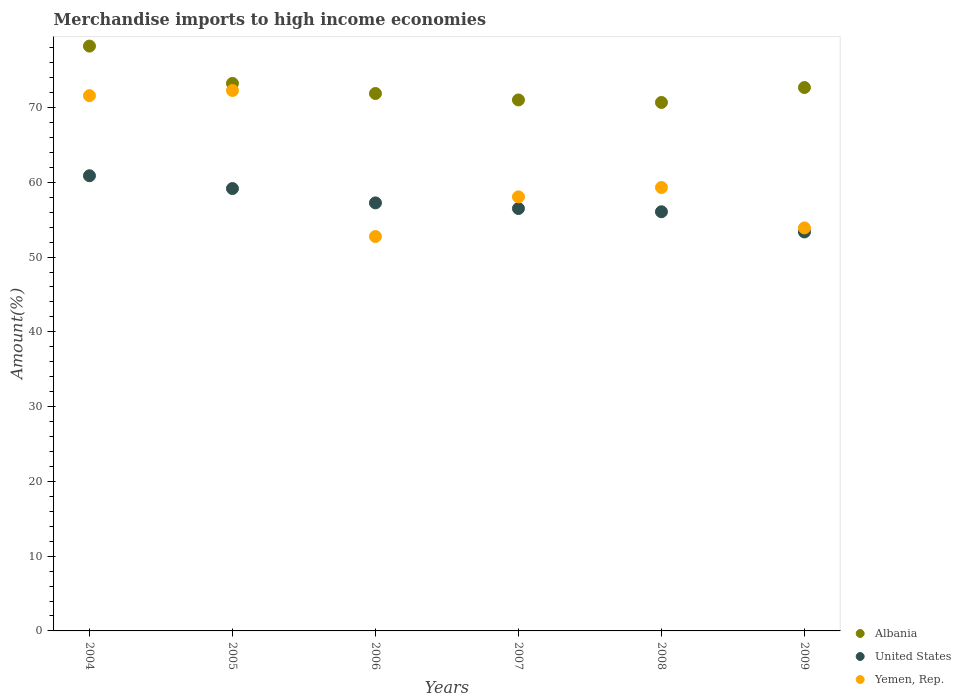How many different coloured dotlines are there?
Provide a succinct answer. 3. What is the percentage of amount earned from merchandise imports in Yemen, Rep. in 2004?
Offer a terse response. 71.59. Across all years, what is the maximum percentage of amount earned from merchandise imports in United States?
Your answer should be very brief. 60.88. Across all years, what is the minimum percentage of amount earned from merchandise imports in United States?
Ensure brevity in your answer.  53.36. In which year was the percentage of amount earned from merchandise imports in Albania maximum?
Offer a terse response. 2004. In which year was the percentage of amount earned from merchandise imports in Albania minimum?
Your answer should be very brief. 2008. What is the total percentage of amount earned from merchandise imports in Yemen, Rep. in the graph?
Give a very brief answer. 367.88. What is the difference between the percentage of amount earned from merchandise imports in United States in 2007 and that in 2008?
Offer a terse response. 0.43. What is the difference between the percentage of amount earned from merchandise imports in Albania in 2008 and the percentage of amount earned from merchandise imports in United States in 2007?
Keep it short and to the point. 14.19. What is the average percentage of amount earned from merchandise imports in Yemen, Rep. per year?
Provide a short and direct response. 61.31. In the year 2008, what is the difference between the percentage of amount earned from merchandise imports in Albania and percentage of amount earned from merchandise imports in United States?
Make the answer very short. 14.62. What is the ratio of the percentage of amount earned from merchandise imports in United States in 2004 to that in 2006?
Make the answer very short. 1.06. Is the percentage of amount earned from merchandise imports in Yemen, Rep. in 2006 less than that in 2007?
Provide a succinct answer. Yes. Is the difference between the percentage of amount earned from merchandise imports in Albania in 2006 and 2009 greater than the difference between the percentage of amount earned from merchandise imports in United States in 2006 and 2009?
Make the answer very short. No. What is the difference between the highest and the second highest percentage of amount earned from merchandise imports in Yemen, Rep.?
Your answer should be very brief. 0.69. What is the difference between the highest and the lowest percentage of amount earned from merchandise imports in Yemen, Rep.?
Offer a very short reply. 19.53. In how many years, is the percentage of amount earned from merchandise imports in Yemen, Rep. greater than the average percentage of amount earned from merchandise imports in Yemen, Rep. taken over all years?
Your answer should be very brief. 2. Is the sum of the percentage of amount earned from merchandise imports in Albania in 2006 and 2009 greater than the maximum percentage of amount earned from merchandise imports in Yemen, Rep. across all years?
Your answer should be very brief. Yes. Does the percentage of amount earned from merchandise imports in United States monotonically increase over the years?
Your answer should be very brief. No. How many dotlines are there?
Make the answer very short. 3. How many years are there in the graph?
Offer a terse response. 6. What is the difference between two consecutive major ticks on the Y-axis?
Provide a short and direct response. 10. Are the values on the major ticks of Y-axis written in scientific E-notation?
Make the answer very short. No. Does the graph contain any zero values?
Your answer should be very brief. No. What is the title of the graph?
Your answer should be very brief. Merchandise imports to high income economies. Does "Cote d'Ivoire" appear as one of the legend labels in the graph?
Give a very brief answer. No. What is the label or title of the Y-axis?
Ensure brevity in your answer.  Amount(%). What is the Amount(%) in Albania in 2004?
Your response must be concise. 78.22. What is the Amount(%) in United States in 2004?
Provide a succinct answer. 60.88. What is the Amount(%) in Yemen, Rep. in 2004?
Your answer should be compact. 71.59. What is the Amount(%) of Albania in 2005?
Provide a succinct answer. 73.23. What is the Amount(%) in United States in 2005?
Provide a succinct answer. 59.17. What is the Amount(%) in Yemen, Rep. in 2005?
Provide a succinct answer. 72.28. What is the Amount(%) of Albania in 2006?
Your answer should be very brief. 71.88. What is the Amount(%) of United States in 2006?
Provide a short and direct response. 57.25. What is the Amount(%) in Yemen, Rep. in 2006?
Provide a short and direct response. 52.75. What is the Amount(%) of Albania in 2007?
Keep it short and to the point. 71.02. What is the Amount(%) in United States in 2007?
Ensure brevity in your answer.  56.49. What is the Amount(%) in Yemen, Rep. in 2007?
Your response must be concise. 58.05. What is the Amount(%) of Albania in 2008?
Your response must be concise. 70.68. What is the Amount(%) of United States in 2008?
Your answer should be compact. 56.06. What is the Amount(%) in Yemen, Rep. in 2008?
Offer a terse response. 59.31. What is the Amount(%) of Albania in 2009?
Your answer should be compact. 72.68. What is the Amount(%) in United States in 2009?
Ensure brevity in your answer.  53.36. What is the Amount(%) in Yemen, Rep. in 2009?
Make the answer very short. 53.9. Across all years, what is the maximum Amount(%) of Albania?
Your response must be concise. 78.22. Across all years, what is the maximum Amount(%) of United States?
Your answer should be very brief. 60.88. Across all years, what is the maximum Amount(%) in Yemen, Rep.?
Give a very brief answer. 72.28. Across all years, what is the minimum Amount(%) in Albania?
Give a very brief answer. 70.68. Across all years, what is the minimum Amount(%) of United States?
Offer a very short reply. 53.36. Across all years, what is the minimum Amount(%) of Yemen, Rep.?
Offer a very short reply. 52.75. What is the total Amount(%) of Albania in the graph?
Offer a terse response. 437.71. What is the total Amount(%) in United States in the graph?
Provide a succinct answer. 343.21. What is the total Amount(%) in Yemen, Rep. in the graph?
Offer a very short reply. 367.88. What is the difference between the Amount(%) of Albania in 2004 and that in 2005?
Give a very brief answer. 4.99. What is the difference between the Amount(%) in United States in 2004 and that in 2005?
Offer a very short reply. 1.71. What is the difference between the Amount(%) in Yemen, Rep. in 2004 and that in 2005?
Give a very brief answer. -0.69. What is the difference between the Amount(%) of Albania in 2004 and that in 2006?
Provide a short and direct response. 6.34. What is the difference between the Amount(%) of United States in 2004 and that in 2006?
Give a very brief answer. 3.63. What is the difference between the Amount(%) of Yemen, Rep. in 2004 and that in 2006?
Offer a terse response. 18.84. What is the difference between the Amount(%) of Albania in 2004 and that in 2007?
Your response must be concise. 7.2. What is the difference between the Amount(%) in United States in 2004 and that in 2007?
Provide a short and direct response. 4.39. What is the difference between the Amount(%) of Yemen, Rep. in 2004 and that in 2007?
Provide a succinct answer. 13.54. What is the difference between the Amount(%) of Albania in 2004 and that in 2008?
Make the answer very short. 7.54. What is the difference between the Amount(%) of United States in 2004 and that in 2008?
Keep it short and to the point. 4.82. What is the difference between the Amount(%) of Yemen, Rep. in 2004 and that in 2008?
Offer a terse response. 12.28. What is the difference between the Amount(%) of Albania in 2004 and that in 2009?
Offer a terse response. 5.54. What is the difference between the Amount(%) in United States in 2004 and that in 2009?
Offer a very short reply. 7.52. What is the difference between the Amount(%) in Yemen, Rep. in 2004 and that in 2009?
Keep it short and to the point. 17.69. What is the difference between the Amount(%) of Albania in 2005 and that in 2006?
Your answer should be very brief. 1.35. What is the difference between the Amount(%) in United States in 2005 and that in 2006?
Make the answer very short. 1.92. What is the difference between the Amount(%) in Yemen, Rep. in 2005 and that in 2006?
Give a very brief answer. 19.53. What is the difference between the Amount(%) in Albania in 2005 and that in 2007?
Provide a short and direct response. 2.21. What is the difference between the Amount(%) of United States in 2005 and that in 2007?
Make the answer very short. 2.67. What is the difference between the Amount(%) in Yemen, Rep. in 2005 and that in 2007?
Provide a short and direct response. 14.23. What is the difference between the Amount(%) of Albania in 2005 and that in 2008?
Your answer should be very brief. 2.55. What is the difference between the Amount(%) of United States in 2005 and that in 2008?
Your answer should be very brief. 3.1. What is the difference between the Amount(%) in Yemen, Rep. in 2005 and that in 2008?
Ensure brevity in your answer.  12.98. What is the difference between the Amount(%) of Albania in 2005 and that in 2009?
Offer a terse response. 0.55. What is the difference between the Amount(%) in United States in 2005 and that in 2009?
Keep it short and to the point. 5.8. What is the difference between the Amount(%) in Yemen, Rep. in 2005 and that in 2009?
Provide a succinct answer. 18.38. What is the difference between the Amount(%) of Albania in 2006 and that in 2007?
Give a very brief answer. 0.86. What is the difference between the Amount(%) in United States in 2006 and that in 2007?
Give a very brief answer. 0.76. What is the difference between the Amount(%) of Yemen, Rep. in 2006 and that in 2007?
Give a very brief answer. -5.3. What is the difference between the Amount(%) in Albania in 2006 and that in 2008?
Give a very brief answer. 1.2. What is the difference between the Amount(%) in United States in 2006 and that in 2008?
Your answer should be very brief. 1.19. What is the difference between the Amount(%) of Yemen, Rep. in 2006 and that in 2008?
Give a very brief answer. -6.56. What is the difference between the Amount(%) in Albania in 2006 and that in 2009?
Give a very brief answer. -0.8. What is the difference between the Amount(%) in United States in 2006 and that in 2009?
Your response must be concise. 3.89. What is the difference between the Amount(%) in Yemen, Rep. in 2006 and that in 2009?
Your answer should be very brief. -1.15. What is the difference between the Amount(%) of Albania in 2007 and that in 2008?
Your response must be concise. 0.34. What is the difference between the Amount(%) in United States in 2007 and that in 2008?
Ensure brevity in your answer.  0.43. What is the difference between the Amount(%) of Yemen, Rep. in 2007 and that in 2008?
Give a very brief answer. -1.25. What is the difference between the Amount(%) in Albania in 2007 and that in 2009?
Provide a short and direct response. -1.66. What is the difference between the Amount(%) of United States in 2007 and that in 2009?
Offer a very short reply. 3.13. What is the difference between the Amount(%) in Yemen, Rep. in 2007 and that in 2009?
Give a very brief answer. 4.15. What is the difference between the Amount(%) of Albania in 2008 and that in 2009?
Offer a terse response. -2. What is the difference between the Amount(%) of United States in 2008 and that in 2009?
Your answer should be very brief. 2.7. What is the difference between the Amount(%) of Yemen, Rep. in 2008 and that in 2009?
Your answer should be very brief. 5.4. What is the difference between the Amount(%) in Albania in 2004 and the Amount(%) in United States in 2005?
Keep it short and to the point. 19.05. What is the difference between the Amount(%) of Albania in 2004 and the Amount(%) of Yemen, Rep. in 2005?
Offer a very short reply. 5.94. What is the difference between the Amount(%) of United States in 2004 and the Amount(%) of Yemen, Rep. in 2005?
Ensure brevity in your answer.  -11.4. What is the difference between the Amount(%) of Albania in 2004 and the Amount(%) of United States in 2006?
Your answer should be compact. 20.97. What is the difference between the Amount(%) in Albania in 2004 and the Amount(%) in Yemen, Rep. in 2006?
Provide a succinct answer. 25.47. What is the difference between the Amount(%) of United States in 2004 and the Amount(%) of Yemen, Rep. in 2006?
Provide a short and direct response. 8.13. What is the difference between the Amount(%) in Albania in 2004 and the Amount(%) in United States in 2007?
Your response must be concise. 21.73. What is the difference between the Amount(%) of Albania in 2004 and the Amount(%) of Yemen, Rep. in 2007?
Offer a very short reply. 20.17. What is the difference between the Amount(%) of United States in 2004 and the Amount(%) of Yemen, Rep. in 2007?
Provide a short and direct response. 2.83. What is the difference between the Amount(%) of Albania in 2004 and the Amount(%) of United States in 2008?
Provide a succinct answer. 22.16. What is the difference between the Amount(%) of Albania in 2004 and the Amount(%) of Yemen, Rep. in 2008?
Provide a short and direct response. 18.91. What is the difference between the Amount(%) of United States in 2004 and the Amount(%) of Yemen, Rep. in 2008?
Provide a succinct answer. 1.57. What is the difference between the Amount(%) in Albania in 2004 and the Amount(%) in United States in 2009?
Ensure brevity in your answer.  24.86. What is the difference between the Amount(%) of Albania in 2004 and the Amount(%) of Yemen, Rep. in 2009?
Ensure brevity in your answer.  24.32. What is the difference between the Amount(%) in United States in 2004 and the Amount(%) in Yemen, Rep. in 2009?
Make the answer very short. 6.98. What is the difference between the Amount(%) of Albania in 2005 and the Amount(%) of United States in 2006?
Your answer should be very brief. 15.98. What is the difference between the Amount(%) of Albania in 2005 and the Amount(%) of Yemen, Rep. in 2006?
Provide a succinct answer. 20.48. What is the difference between the Amount(%) of United States in 2005 and the Amount(%) of Yemen, Rep. in 2006?
Offer a very short reply. 6.42. What is the difference between the Amount(%) in Albania in 2005 and the Amount(%) in United States in 2007?
Provide a short and direct response. 16.74. What is the difference between the Amount(%) of Albania in 2005 and the Amount(%) of Yemen, Rep. in 2007?
Provide a succinct answer. 15.18. What is the difference between the Amount(%) in United States in 2005 and the Amount(%) in Yemen, Rep. in 2007?
Your response must be concise. 1.11. What is the difference between the Amount(%) of Albania in 2005 and the Amount(%) of United States in 2008?
Provide a short and direct response. 17.17. What is the difference between the Amount(%) of Albania in 2005 and the Amount(%) of Yemen, Rep. in 2008?
Provide a short and direct response. 13.92. What is the difference between the Amount(%) of United States in 2005 and the Amount(%) of Yemen, Rep. in 2008?
Ensure brevity in your answer.  -0.14. What is the difference between the Amount(%) of Albania in 2005 and the Amount(%) of United States in 2009?
Make the answer very short. 19.87. What is the difference between the Amount(%) of Albania in 2005 and the Amount(%) of Yemen, Rep. in 2009?
Make the answer very short. 19.33. What is the difference between the Amount(%) in United States in 2005 and the Amount(%) in Yemen, Rep. in 2009?
Keep it short and to the point. 5.26. What is the difference between the Amount(%) in Albania in 2006 and the Amount(%) in United States in 2007?
Offer a terse response. 15.39. What is the difference between the Amount(%) of Albania in 2006 and the Amount(%) of Yemen, Rep. in 2007?
Ensure brevity in your answer.  13.83. What is the difference between the Amount(%) of United States in 2006 and the Amount(%) of Yemen, Rep. in 2007?
Keep it short and to the point. -0.8. What is the difference between the Amount(%) of Albania in 2006 and the Amount(%) of United States in 2008?
Give a very brief answer. 15.82. What is the difference between the Amount(%) of Albania in 2006 and the Amount(%) of Yemen, Rep. in 2008?
Give a very brief answer. 12.57. What is the difference between the Amount(%) in United States in 2006 and the Amount(%) in Yemen, Rep. in 2008?
Provide a short and direct response. -2.06. What is the difference between the Amount(%) of Albania in 2006 and the Amount(%) of United States in 2009?
Keep it short and to the point. 18.52. What is the difference between the Amount(%) in Albania in 2006 and the Amount(%) in Yemen, Rep. in 2009?
Offer a terse response. 17.98. What is the difference between the Amount(%) of United States in 2006 and the Amount(%) of Yemen, Rep. in 2009?
Ensure brevity in your answer.  3.35. What is the difference between the Amount(%) in Albania in 2007 and the Amount(%) in United States in 2008?
Provide a short and direct response. 14.96. What is the difference between the Amount(%) in Albania in 2007 and the Amount(%) in Yemen, Rep. in 2008?
Give a very brief answer. 11.71. What is the difference between the Amount(%) of United States in 2007 and the Amount(%) of Yemen, Rep. in 2008?
Keep it short and to the point. -2.81. What is the difference between the Amount(%) in Albania in 2007 and the Amount(%) in United States in 2009?
Provide a succinct answer. 17.66. What is the difference between the Amount(%) in Albania in 2007 and the Amount(%) in Yemen, Rep. in 2009?
Give a very brief answer. 17.12. What is the difference between the Amount(%) in United States in 2007 and the Amount(%) in Yemen, Rep. in 2009?
Offer a very short reply. 2.59. What is the difference between the Amount(%) of Albania in 2008 and the Amount(%) of United States in 2009?
Ensure brevity in your answer.  17.32. What is the difference between the Amount(%) of Albania in 2008 and the Amount(%) of Yemen, Rep. in 2009?
Give a very brief answer. 16.78. What is the difference between the Amount(%) in United States in 2008 and the Amount(%) in Yemen, Rep. in 2009?
Your answer should be compact. 2.16. What is the average Amount(%) of Albania per year?
Keep it short and to the point. 72.95. What is the average Amount(%) of United States per year?
Your answer should be very brief. 57.2. What is the average Amount(%) of Yemen, Rep. per year?
Give a very brief answer. 61.31. In the year 2004, what is the difference between the Amount(%) in Albania and Amount(%) in United States?
Provide a succinct answer. 17.34. In the year 2004, what is the difference between the Amount(%) of Albania and Amount(%) of Yemen, Rep.?
Keep it short and to the point. 6.63. In the year 2004, what is the difference between the Amount(%) in United States and Amount(%) in Yemen, Rep.?
Ensure brevity in your answer.  -10.71. In the year 2005, what is the difference between the Amount(%) in Albania and Amount(%) in United States?
Provide a short and direct response. 14.06. In the year 2005, what is the difference between the Amount(%) of Albania and Amount(%) of Yemen, Rep.?
Provide a succinct answer. 0.95. In the year 2005, what is the difference between the Amount(%) of United States and Amount(%) of Yemen, Rep.?
Your response must be concise. -13.12. In the year 2006, what is the difference between the Amount(%) of Albania and Amount(%) of United States?
Your response must be concise. 14.63. In the year 2006, what is the difference between the Amount(%) in Albania and Amount(%) in Yemen, Rep.?
Your answer should be very brief. 19.13. In the year 2006, what is the difference between the Amount(%) of United States and Amount(%) of Yemen, Rep.?
Your response must be concise. 4.5. In the year 2007, what is the difference between the Amount(%) in Albania and Amount(%) in United States?
Offer a terse response. 14.53. In the year 2007, what is the difference between the Amount(%) of Albania and Amount(%) of Yemen, Rep.?
Keep it short and to the point. 12.97. In the year 2007, what is the difference between the Amount(%) of United States and Amount(%) of Yemen, Rep.?
Your response must be concise. -1.56. In the year 2008, what is the difference between the Amount(%) of Albania and Amount(%) of United States?
Provide a succinct answer. 14.62. In the year 2008, what is the difference between the Amount(%) in Albania and Amount(%) in Yemen, Rep.?
Make the answer very short. 11.37. In the year 2008, what is the difference between the Amount(%) of United States and Amount(%) of Yemen, Rep.?
Ensure brevity in your answer.  -3.24. In the year 2009, what is the difference between the Amount(%) of Albania and Amount(%) of United States?
Your response must be concise. 19.32. In the year 2009, what is the difference between the Amount(%) of Albania and Amount(%) of Yemen, Rep.?
Provide a succinct answer. 18.78. In the year 2009, what is the difference between the Amount(%) in United States and Amount(%) in Yemen, Rep.?
Give a very brief answer. -0.54. What is the ratio of the Amount(%) in Albania in 2004 to that in 2005?
Your answer should be compact. 1.07. What is the ratio of the Amount(%) of United States in 2004 to that in 2005?
Your answer should be very brief. 1.03. What is the ratio of the Amount(%) of Albania in 2004 to that in 2006?
Offer a terse response. 1.09. What is the ratio of the Amount(%) of United States in 2004 to that in 2006?
Your answer should be very brief. 1.06. What is the ratio of the Amount(%) of Yemen, Rep. in 2004 to that in 2006?
Ensure brevity in your answer.  1.36. What is the ratio of the Amount(%) in Albania in 2004 to that in 2007?
Provide a succinct answer. 1.1. What is the ratio of the Amount(%) of United States in 2004 to that in 2007?
Provide a short and direct response. 1.08. What is the ratio of the Amount(%) in Yemen, Rep. in 2004 to that in 2007?
Provide a succinct answer. 1.23. What is the ratio of the Amount(%) in Albania in 2004 to that in 2008?
Make the answer very short. 1.11. What is the ratio of the Amount(%) of United States in 2004 to that in 2008?
Your answer should be compact. 1.09. What is the ratio of the Amount(%) of Yemen, Rep. in 2004 to that in 2008?
Provide a succinct answer. 1.21. What is the ratio of the Amount(%) in Albania in 2004 to that in 2009?
Provide a succinct answer. 1.08. What is the ratio of the Amount(%) in United States in 2004 to that in 2009?
Your answer should be compact. 1.14. What is the ratio of the Amount(%) in Yemen, Rep. in 2004 to that in 2009?
Provide a succinct answer. 1.33. What is the ratio of the Amount(%) in Albania in 2005 to that in 2006?
Provide a succinct answer. 1.02. What is the ratio of the Amount(%) in United States in 2005 to that in 2006?
Your answer should be very brief. 1.03. What is the ratio of the Amount(%) in Yemen, Rep. in 2005 to that in 2006?
Offer a terse response. 1.37. What is the ratio of the Amount(%) of Albania in 2005 to that in 2007?
Offer a very short reply. 1.03. What is the ratio of the Amount(%) of United States in 2005 to that in 2007?
Provide a succinct answer. 1.05. What is the ratio of the Amount(%) in Yemen, Rep. in 2005 to that in 2007?
Give a very brief answer. 1.25. What is the ratio of the Amount(%) of Albania in 2005 to that in 2008?
Keep it short and to the point. 1.04. What is the ratio of the Amount(%) in United States in 2005 to that in 2008?
Offer a very short reply. 1.06. What is the ratio of the Amount(%) in Yemen, Rep. in 2005 to that in 2008?
Ensure brevity in your answer.  1.22. What is the ratio of the Amount(%) in Albania in 2005 to that in 2009?
Your answer should be very brief. 1.01. What is the ratio of the Amount(%) in United States in 2005 to that in 2009?
Offer a terse response. 1.11. What is the ratio of the Amount(%) in Yemen, Rep. in 2005 to that in 2009?
Offer a very short reply. 1.34. What is the ratio of the Amount(%) of Albania in 2006 to that in 2007?
Your response must be concise. 1.01. What is the ratio of the Amount(%) of United States in 2006 to that in 2007?
Provide a short and direct response. 1.01. What is the ratio of the Amount(%) of Yemen, Rep. in 2006 to that in 2007?
Offer a very short reply. 0.91. What is the ratio of the Amount(%) in Albania in 2006 to that in 2008?
Your response must be concise. 1.02. What is the ratio of the Amount(%) of United States in 2006 to that in 2008?
Provide a short and direct response. 1.02. What is the ratio of the Amount(%) of Yemen, Rep. in 2006 to that in 2008?
Keep it short and to the point. 0.89. What is the ratio of the Amount(%) in Albania in 2006 to that in 2009?
Your response must be concise. 0.99. What is the ratio of the Amount(%) in United States in 2006 to that in 2009?
Your answer should be compact. 1.07. What is the ratio of the Amount(%) of Yemen, Rep. in 2006 to that in 2009?
Make the answer very short. 0.98. What is the ratio of the Amount(%) in United States in 2007 to that in 2008?
Ensure brevity in your answer.  1.01. What is the ratio of the Amount(%) of Yemen, Rep. in 2007 to that in 2008?
Ensure brevity in your answer.  0.98. What is the ratio of the Amount(%) of Albania in 2007 to that in 2009?
Provide a short and direct response. 0.98. What is the ratio of the Amount(%) of United States in 2007 to that in 2009?
Provide a short and direct response. 1.06. What is the ratio of the Amount(%) of Yemen, Rep. in 2007 to that in 2009?
Make the answer very short. 1.08. What is the ratio of the Amount(%) in Albania in 2008 to that in 2009?
Your answer should be very brief. 0.97. What is the ratio of the Amount(%) of United States in 2008 to that in 2009?
Offer a very short reply. 1.05. What is the ratio of the Amount(%) in Yemen, Rep. in 2008 to that in 2009?
Provide a succinct answer. 1.1. What is the difference between the highest and the second highest Amount(%) in Albania?
Your answer should be compact. 4.99. What is the difference between the highest and the second highest Amount(%) of United States?
Offer a very short reply. 1.71. What is the difference between the highest and the second highest Amount(%) of Yemen, Rep.?
Keep it short and to the point. 0.69. What is the difference between the highest and the lowest Amount(%) of Albania?
Keep it short and to the point. 7.54. What is the difference between the highest and the lowest Amount(%) of United States?
Keep it short and to the point. 7.52. What is the difference between the highest and the lowest Amount(%) of Yemen, Rep.?
Provide a succinct answer. 19.53. 